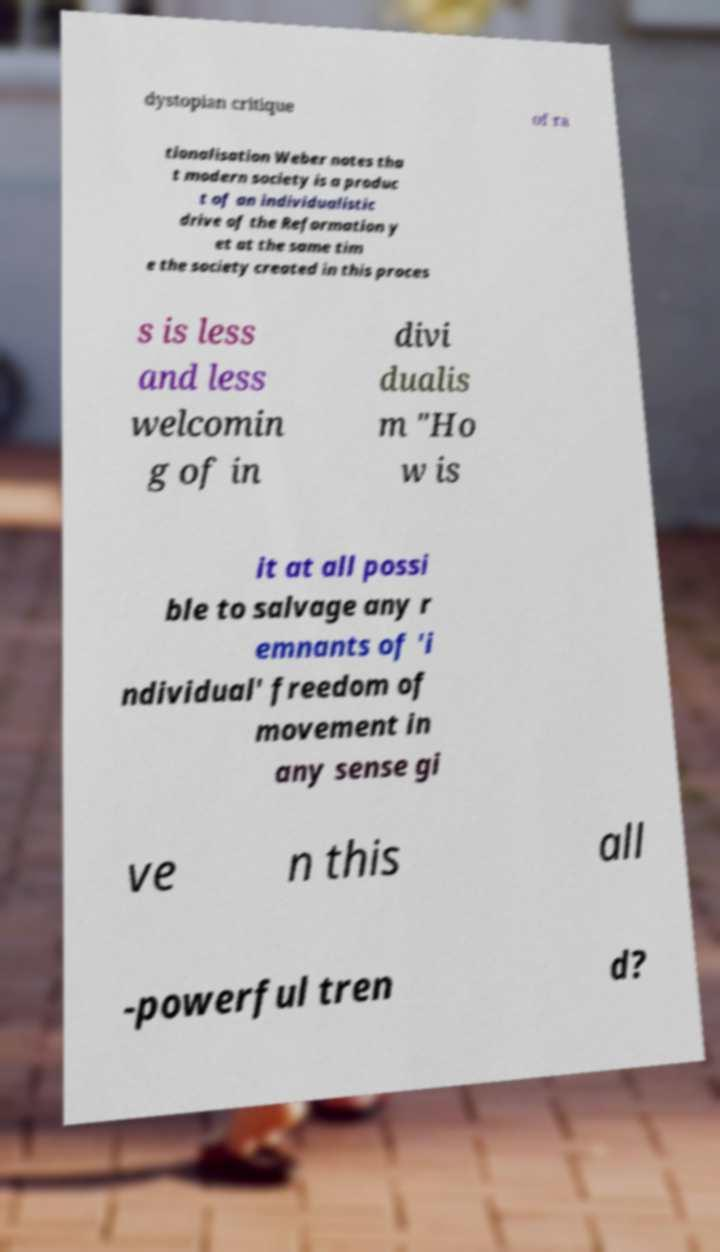Can you read and provide the text displayed in the image?This photo seems to have some interesting text. Can you extract and type it out for me? dystopian critique of ra tionalisation Weber notes tha t modern society is a produc t of an individualistic drive of the Reformation y et at the same tim e the society created in this proces s is less and less welcomin g of in divi dualis m "Ho w is it at all possi ble to salvage any r emnants of 'i ndividual' freedom of movement in any sense gi ve n this all -powerful tren d? 